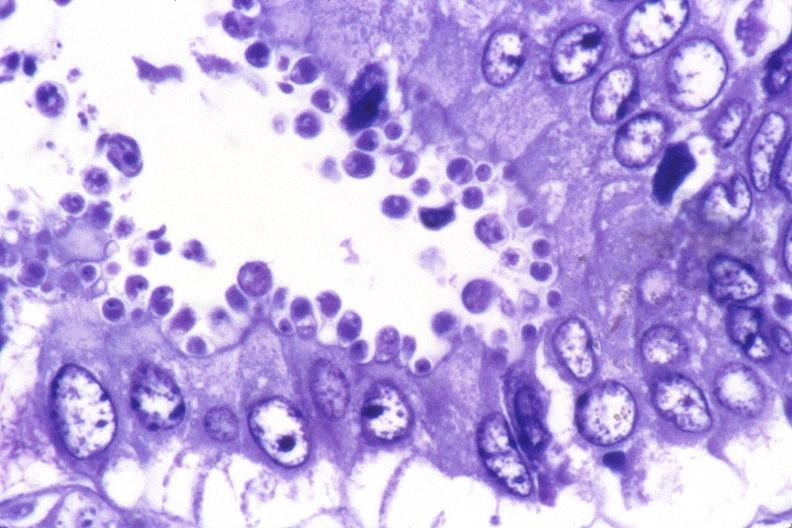what is present?
Answer the question using a single word or phrase. Gastrointestinal 